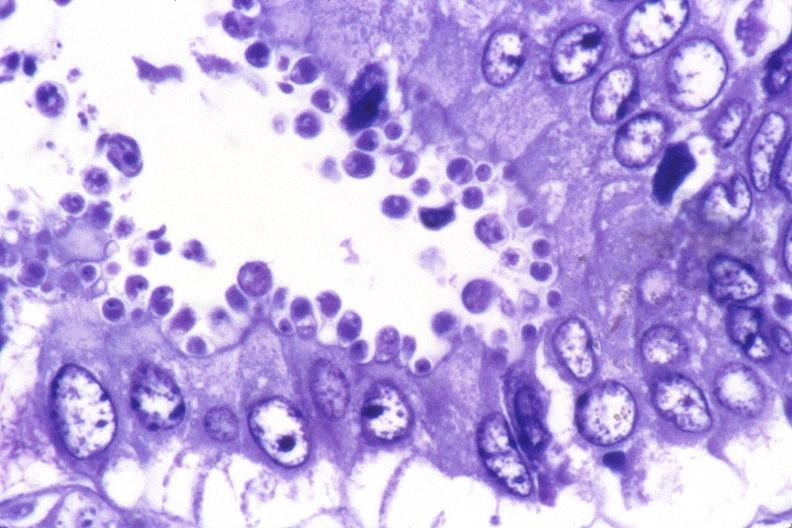what is present?
Answer the question using a single word or phrase. Gastrointestinal 